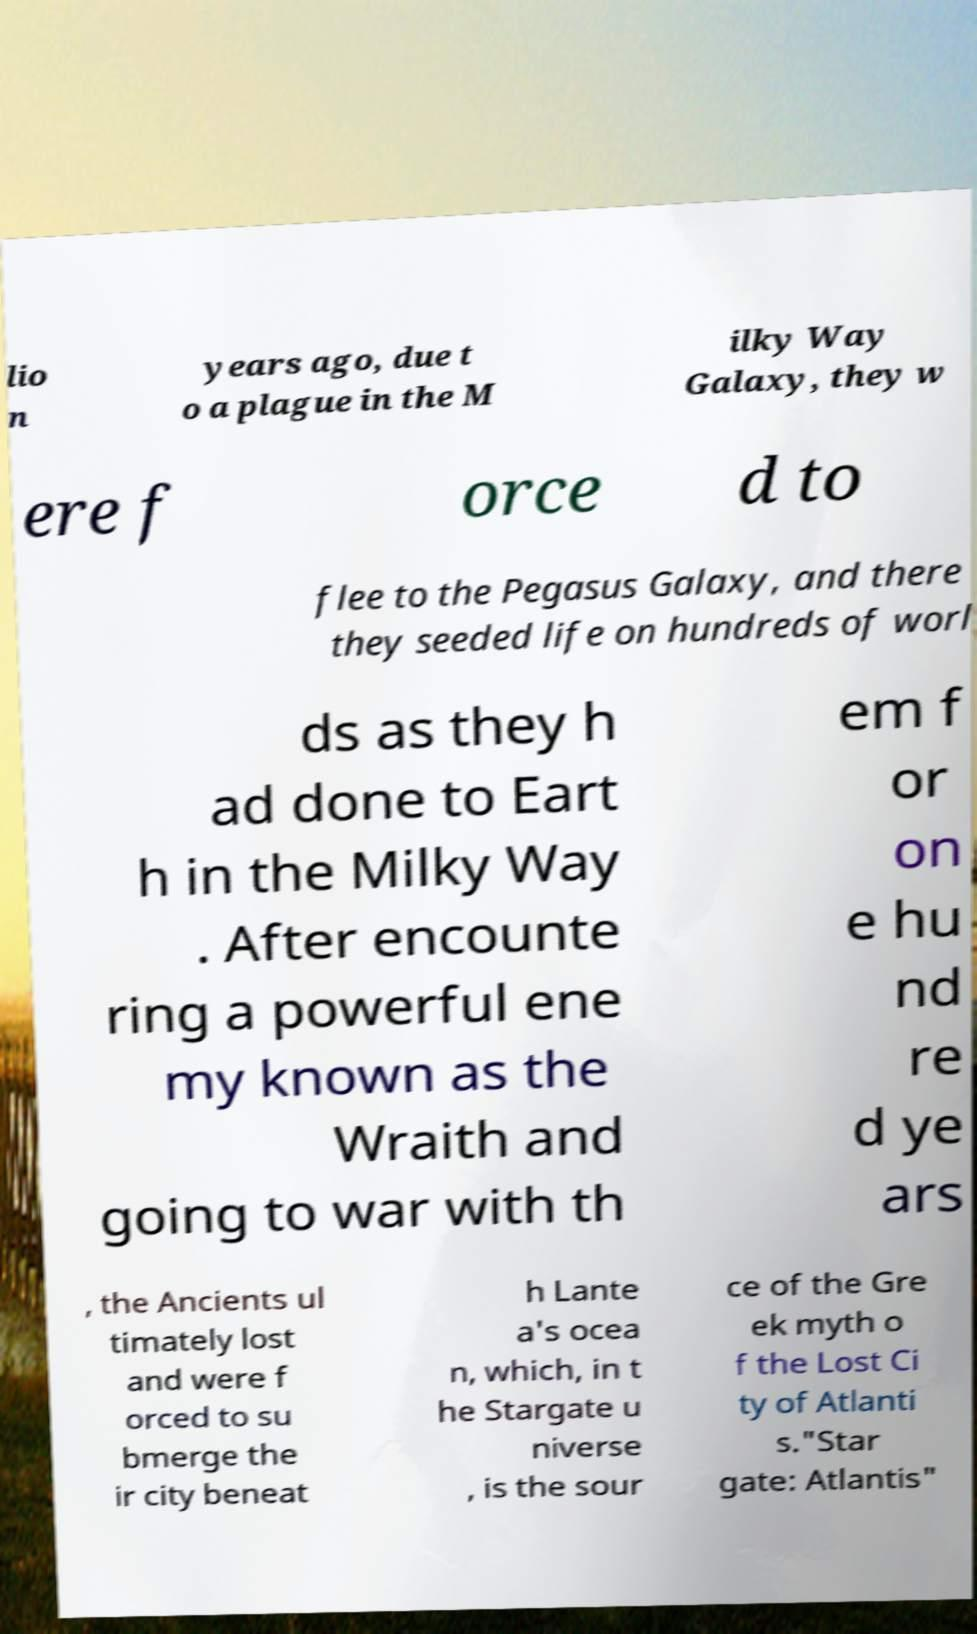There's text embedded in this image that I need extracted. Can you transcribe it verbatim? lio n years ago, due t o a plague in the M ilky Way Galaxy, they w ere f orce d to flee to the Pegasus Galaxy, and there they seeded life on hundreds of worl ds as they h ad done to Eart h in the Milky Way . After encounte ring a powerful ene my known as the Wraith and going to war with th em f or on e hu nd re d ye ars , the Ancients ul timately lost and were f orced to su bmerge the ir city beneat h Lante a's ocea n, which, in t he Stargate u niverse , is the sour ce of the Gre ek myth o f the Lost Ci ty of Atlanti s."Star gate: Atlantis" 